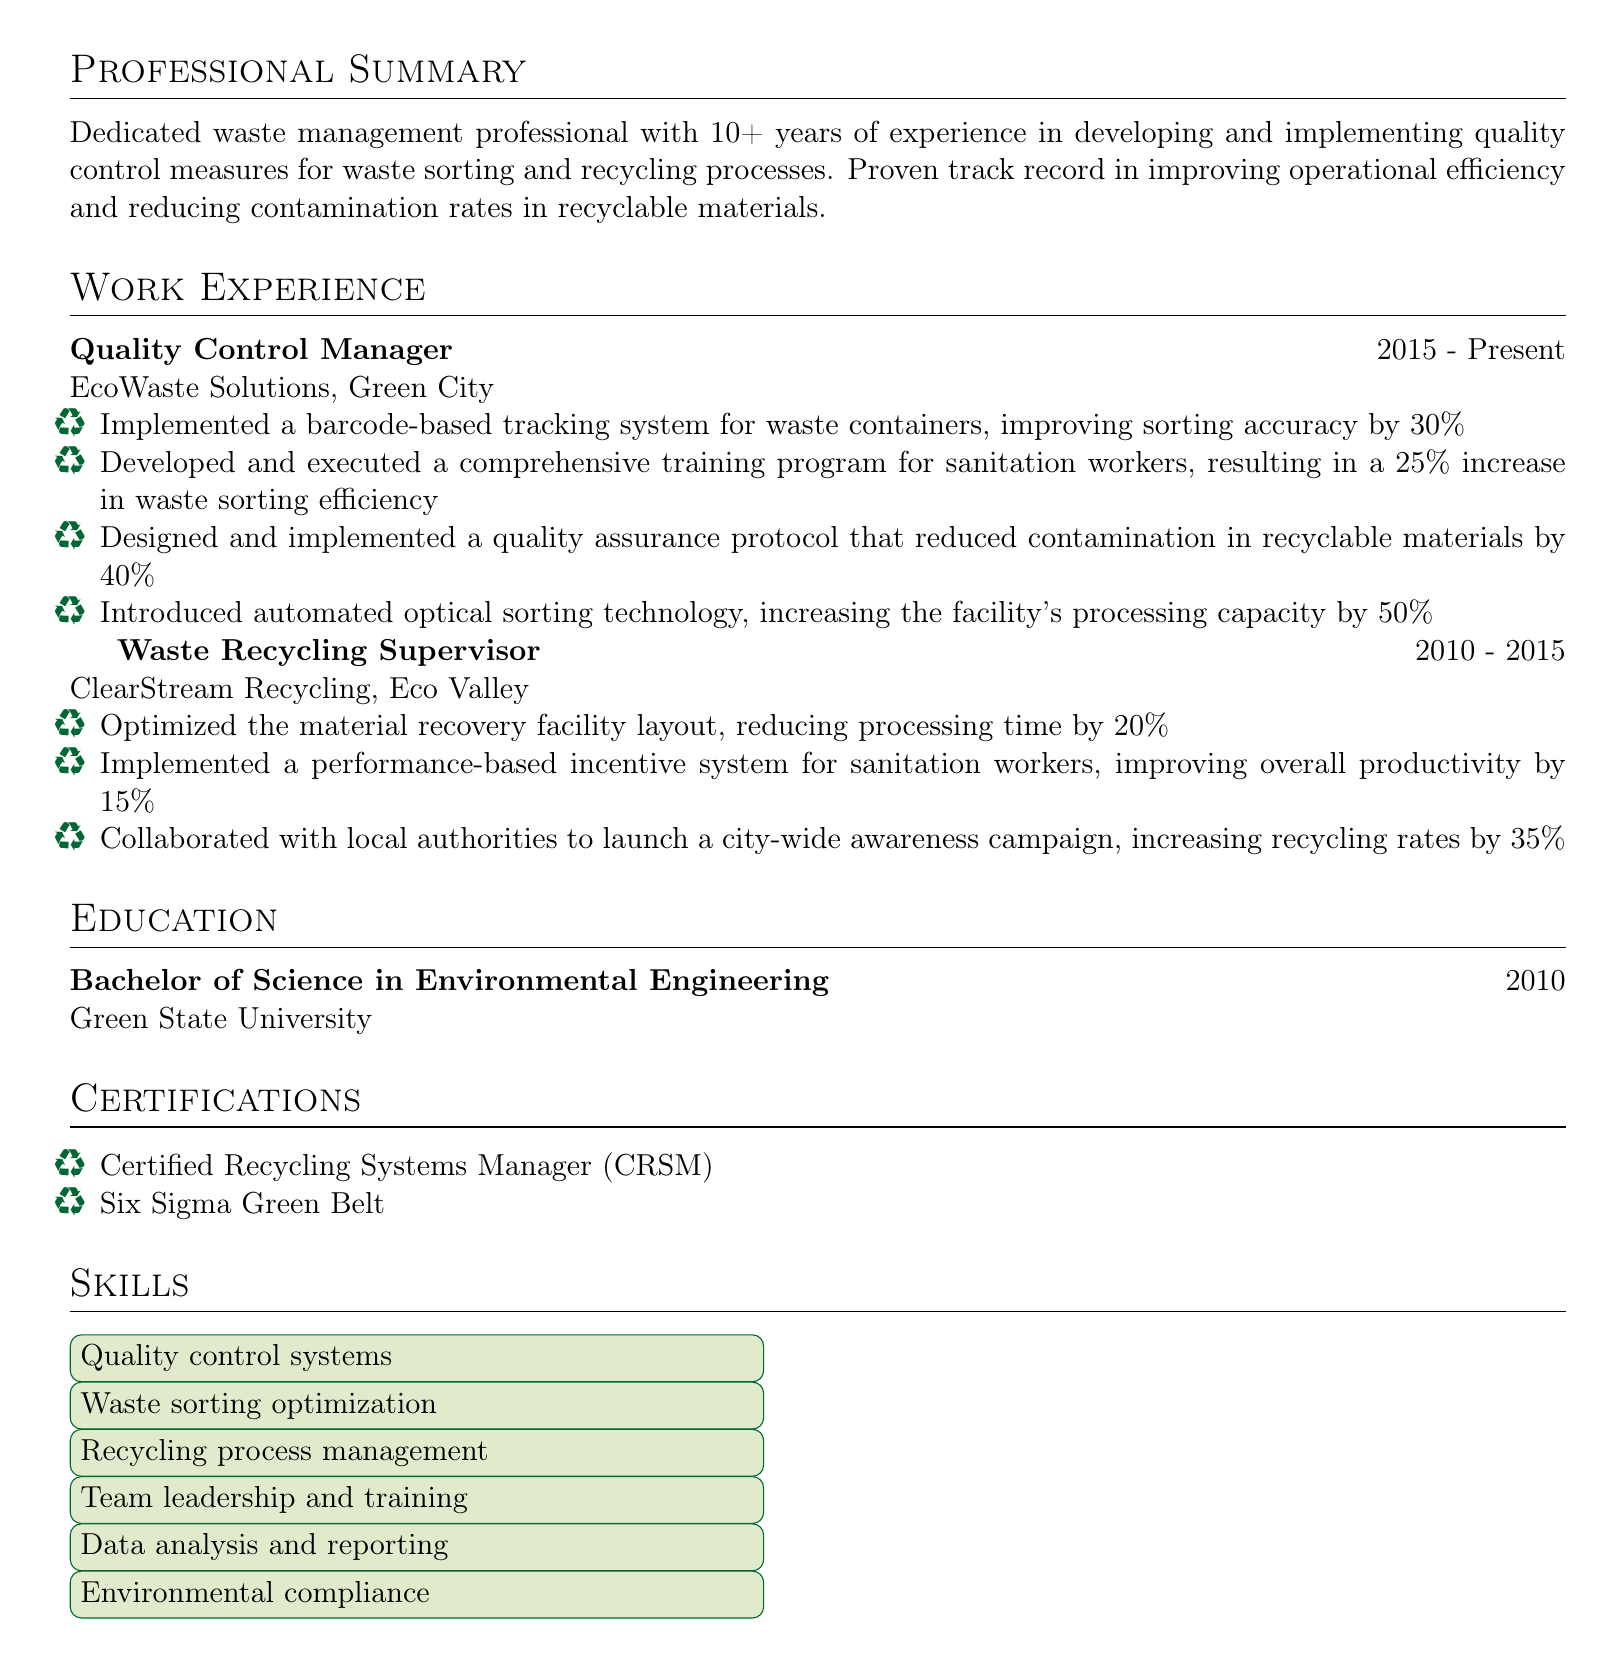What is the name of the individual? The document provides the name of the individual at the top, which is Alex Thompson.
Answer: Alex Thompson What is the title under which they work? The title is listed below the name in the document, which is Quality Control Manager.
Answer: Quality Control Manager What percentage increase in waste sorting efficiency resulted from the training program? The document states that the training program resulted in a 25% increase in waste sorting efficiency.
Answer: 25% In which year did Alex Thompson graduate? The document indicates that Alex graduated in 2010.
Answer: 2010 How many years of experience does Alex have in waste management? The professional summary states that Alex has over 10 years of experience in waste management.
Answer: 10+ What technology was introduced to increase the facility's processing capacity? The document specifies that automated optical sorting technology was introduced.
Answer: Automated optical sorting technology What is one certification that Alex holds? The document lists the certifications, and one of them is Certified Recycling Systems Manager.
Answer: Certified Recycling Systems Manager Which company did Alex work for as a Waste Recycling Supervisor? The document states that Alex worked as a Waste Recycling Supervisor for ClearStream Recycling.
Answer: ClearStream Recycling What was the achievement related to the performance-based incentive system? The document notes that the incentive system improved overall productivity by 15%.
Answer: 15% 